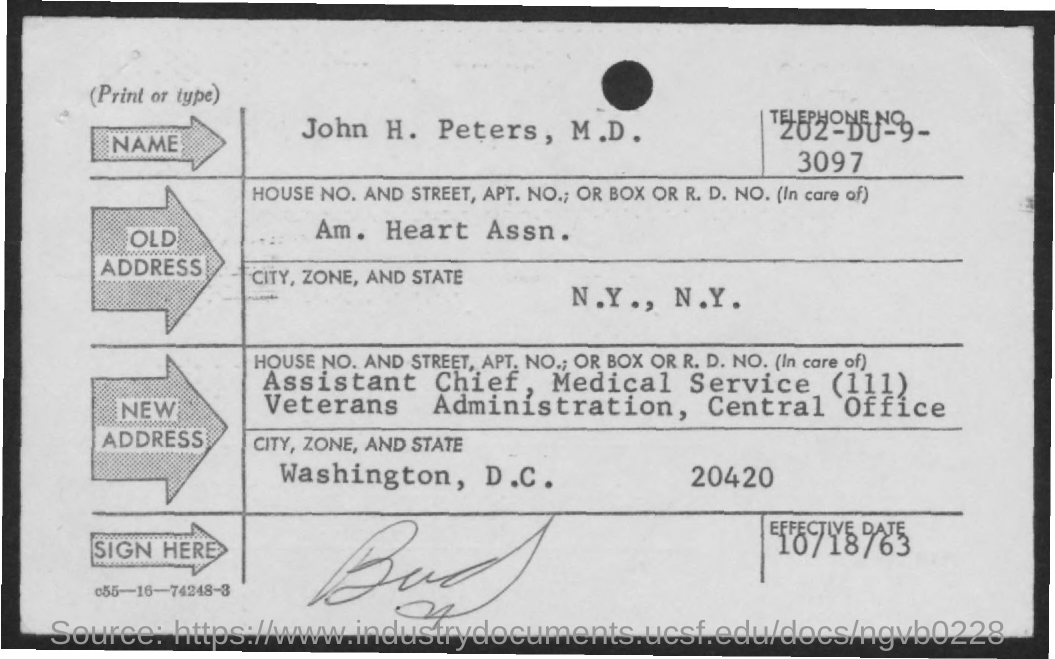What is the telephone number given in the form?
Offer a terse response. 202-DU-9-3097. What is the effective date?
Provide a succinct answer. 10/18/63. 